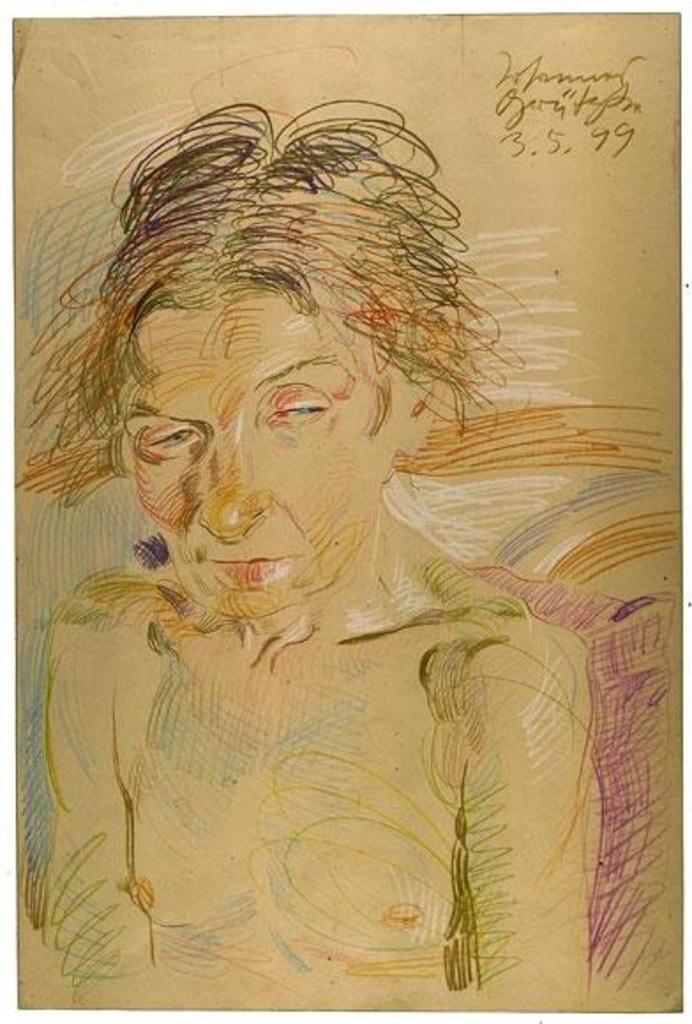How would you summarize this image in a sentence or two? Here we can see a drawing of a woman is leaning on a pillow on a platform. At the top corner on the right we can see texts written on the platform. 